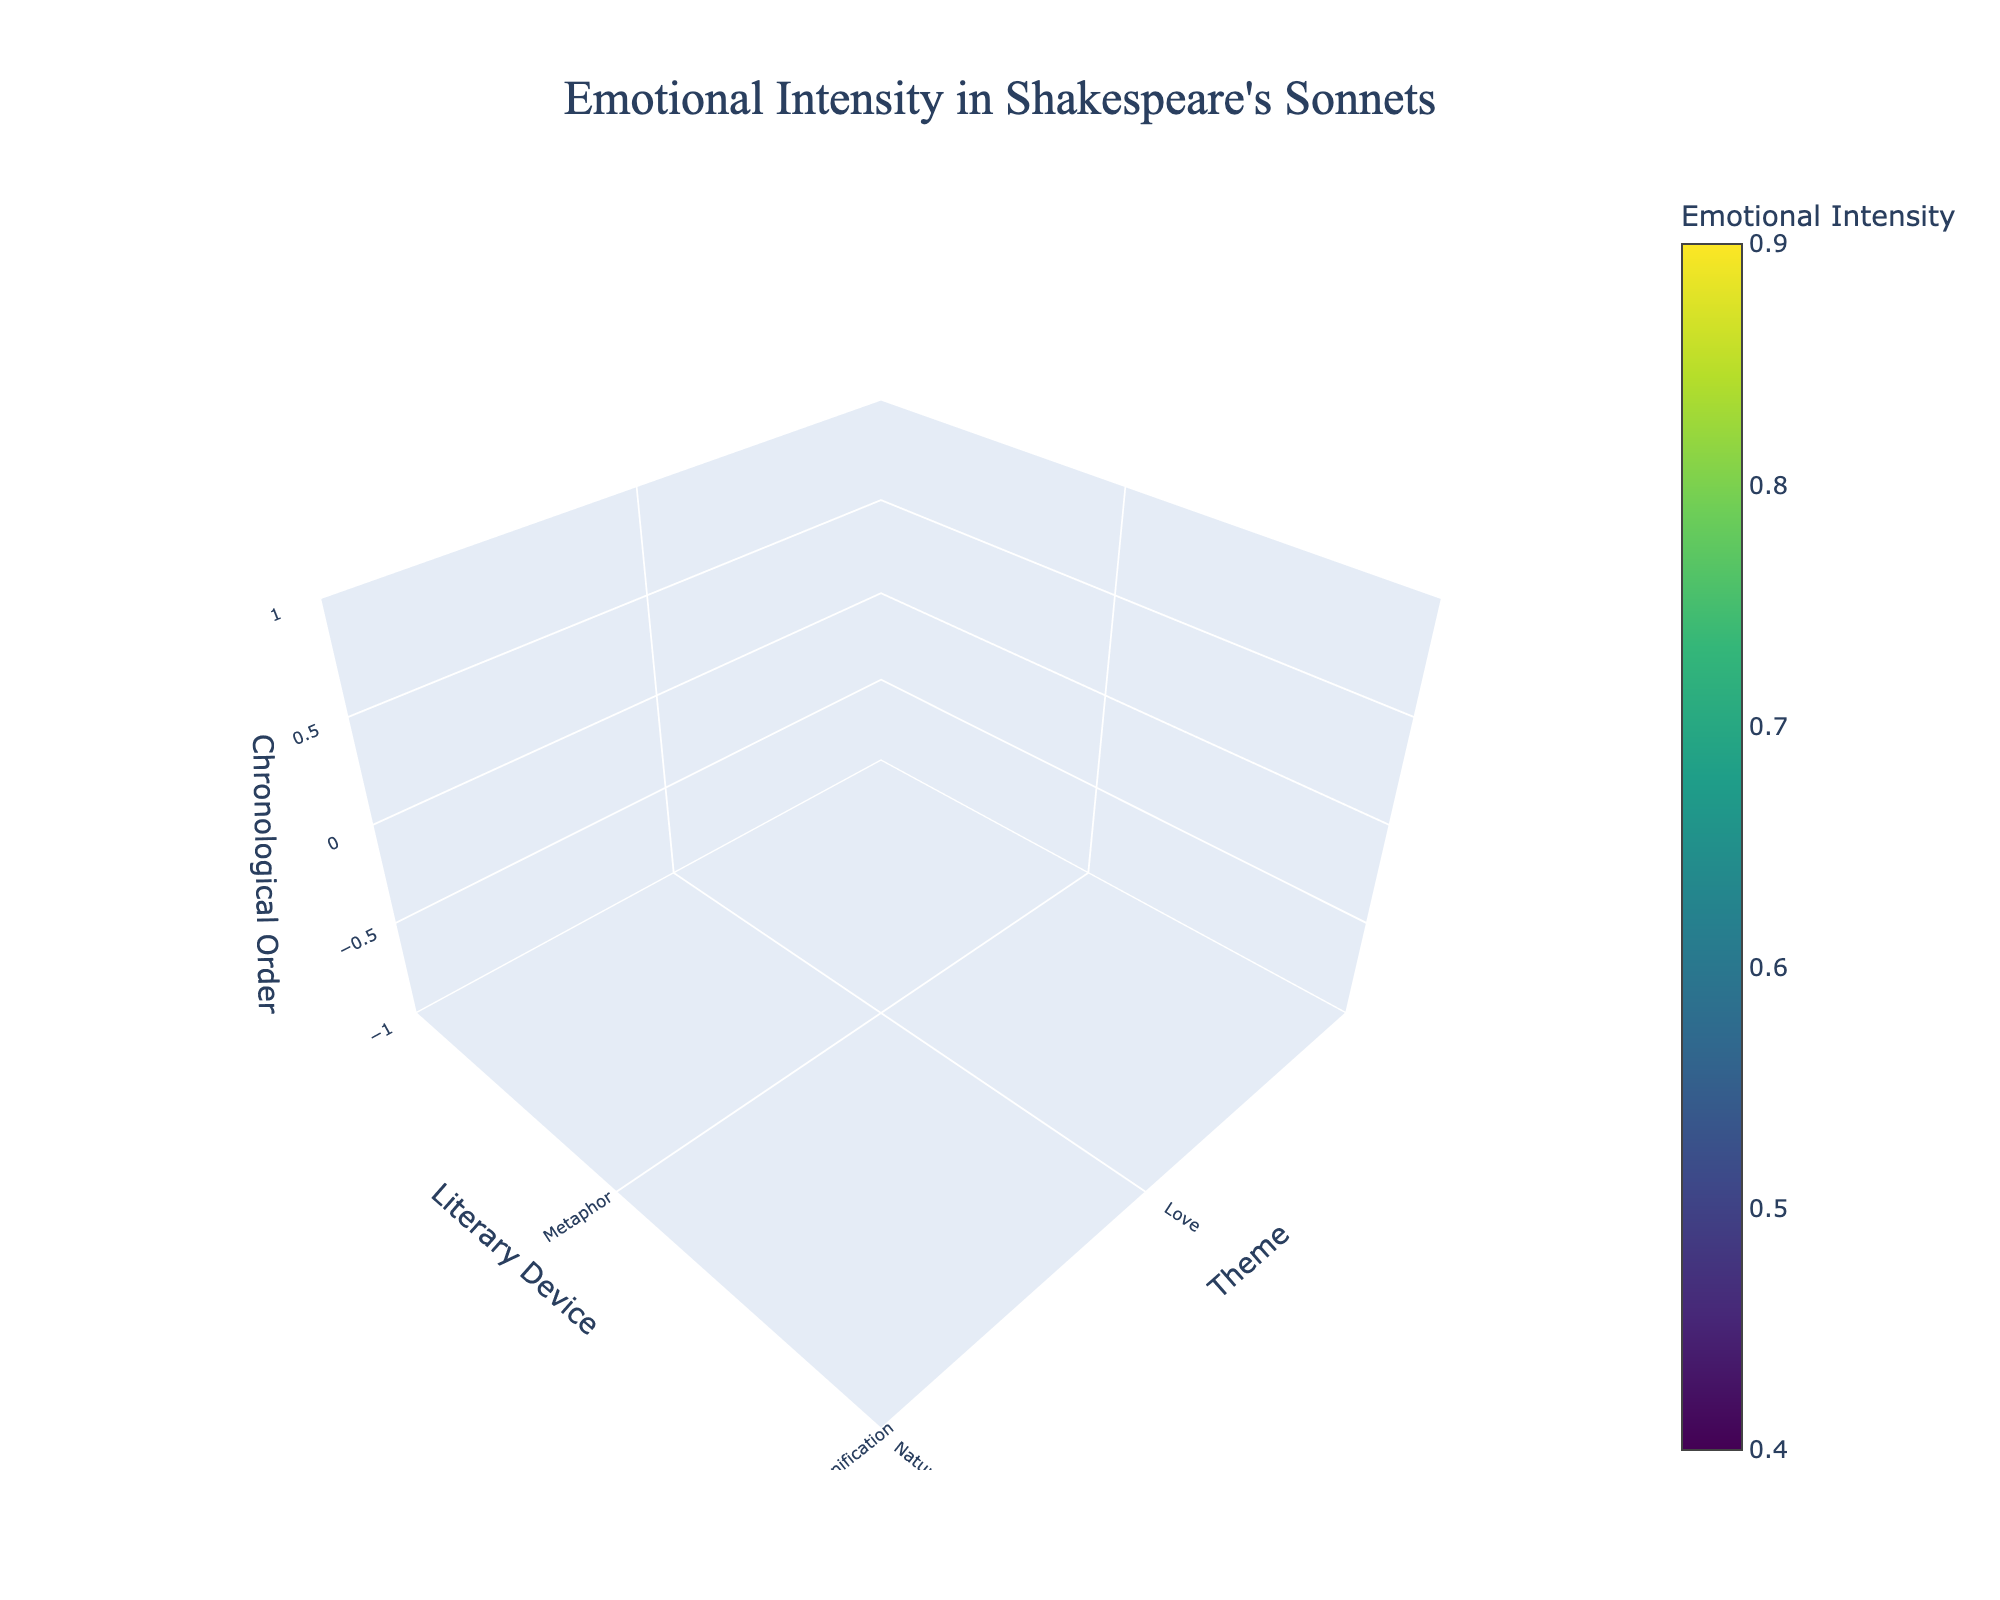How many themes are mapped in the figure? To find out how many themes are represented, we can inspect the x-axis where themes are listed. There are 10 themes in the dataset.
Answer: 10 What is the title of the figure? The title of the figure is displayed prominently at the top of the plot.
Answer: Emotional Intensity in Shakespeare's Sonnets Which theme has the highest emotional intensity value? To find the theme with the highest emotional intensity, look for the maximum value on the color scale and identify its corresponding theme on the x-axis. The highest value is 0.9, which corresponds to the themes "Beauty" and "Betrayal."
Answer: Beauty and Betrayal What is the emotional intensity of the sonnet occurring at chronological order 30? Locate the point along the z-axis (chronological order) at 30. The emotional intensity value associated with this point is 0.7.
Answer: 0.7 Are there any literary devices associated with an emotional intensity of 0.4? Check the color-coded volume plot for the color representing 0.4 and identify the corresponding literary device. The literary device associated with 0.4 is "Assonance."
Answer: Assonance What is the average emotional intensity of the sonnets associated with the theme "Jealousy"? All "Jealousy" related sonnets are represented by a single data point with an emotional intensity of 0.8. Since there's only one data point, the average is 0.8.
Answer: 0.8 Compare the emotional intensities of "Nature" and "Lust" themes. Which is higher? Identify the data points for "Nature" and "Lust" themes on the x-axis and compare their intensity values from the colors. "Nature" has an intensity of 0.6, and "Lust" has an intensity of 0.6; hence, both have the same intensity.
Answer: Both have the same intensity Which theme is associated with the literary device "Metaphor," and what is its emotional intensity? Find the literary device "Metaphor" on the y-axis and look for the corresponding theme and emotional intensity value along the x-axis and the color scale. The theme is "Love," and its intensity is 0.8.
Answer: Love, 0.8 In what chronological order does the theme "Betrayal" occur, and what are the associated literary device and emotional intensity? Locate the theme "Betrayal" on the x-axis and follow its corresponding point to the y and z axes and the color scale. "Betrayal" occurs at chronological order 135, with the literary device "Paradox," and an emotional intensity of 0.9.
Answer: 135, Paradox, 0.9 What's the difference in emotional intensity between the themes "Death" and "Mortality"? Identify the emotional intensities of "Death" and "Mortality" on the color scale. "Death" has an intensity of 0.5, while "Mortality" has an intensity of 0.7. The difference is 0.7 - 0.5.
Answer: 0.2 